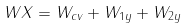Convert formula to latex. <formula><loc_0><loc_0><loc_500><loc_500>W X = W _ { c v } + W _ { 1 y } + W _ { 2 y }</formula> 